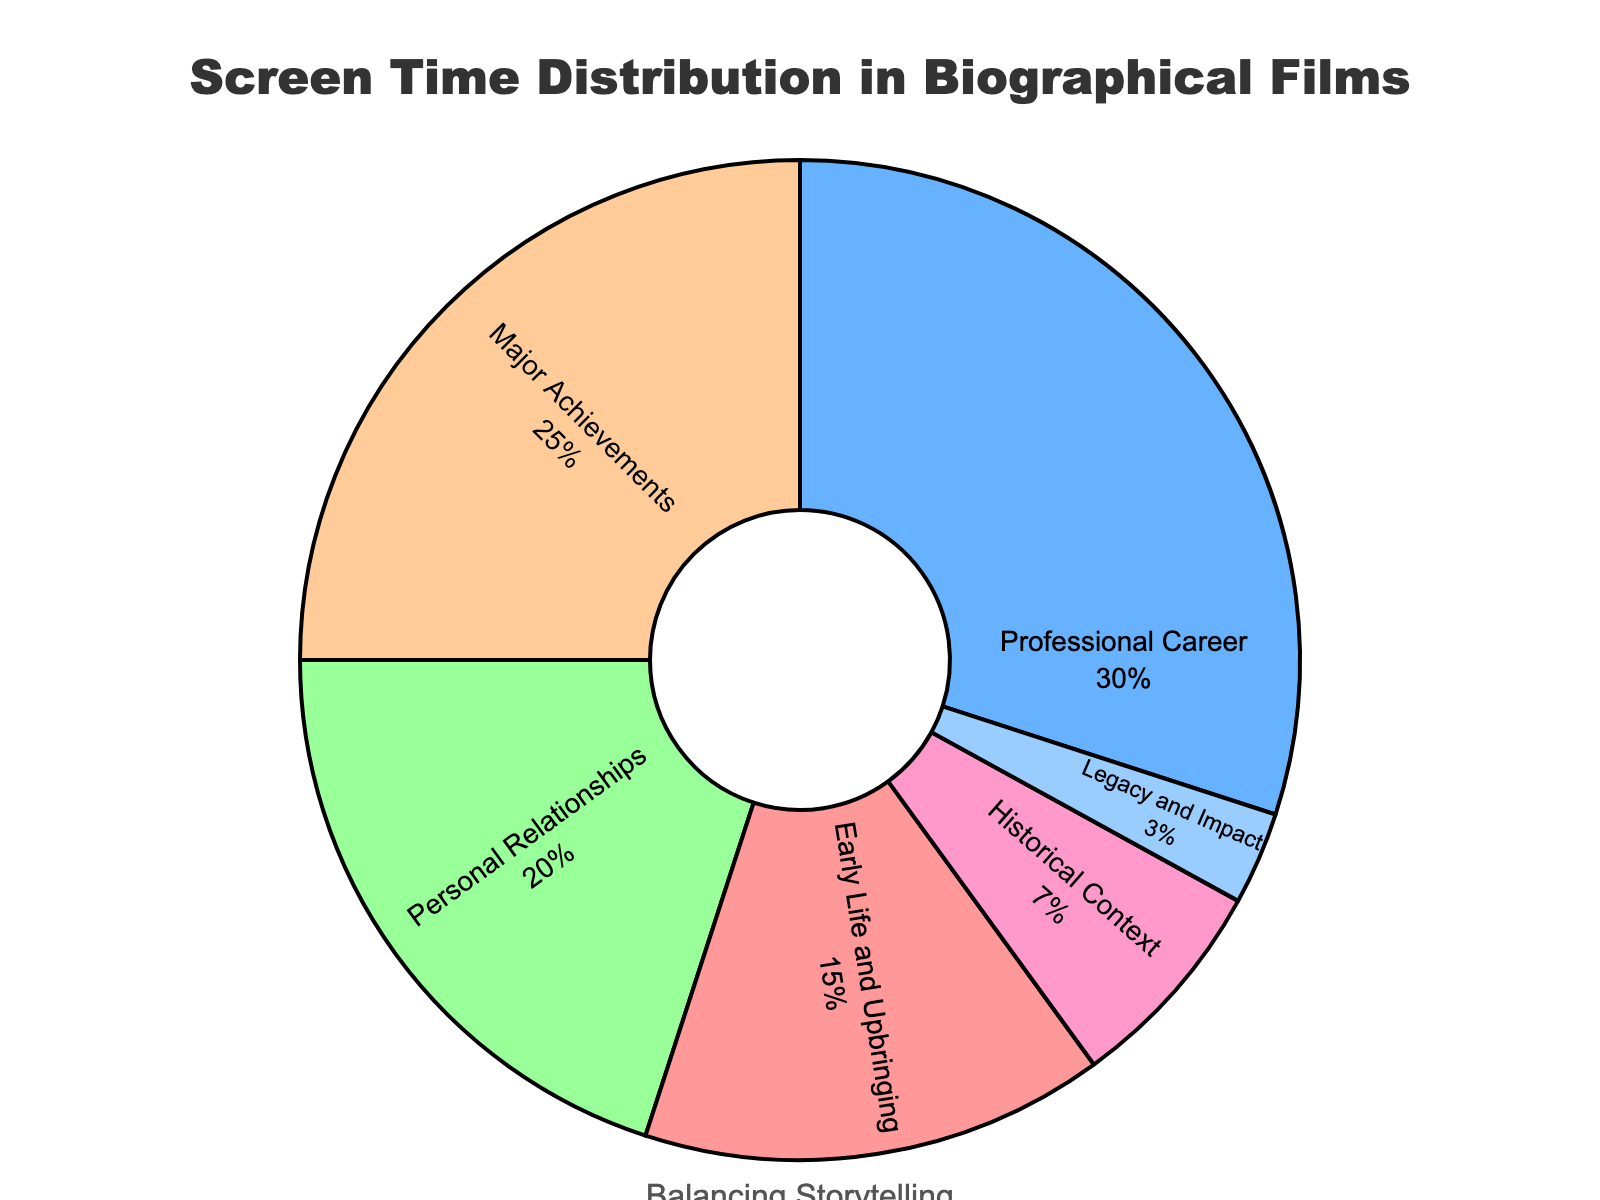Which aspect of the subject's life has the highest screen time percentage? Identify the segment with the largest proportion in the pie chart by comparing the percentages labeled for each aspect directly.
Answer: Professional Career How much more screen time is dedicated to Major Achievements than to Historical Context? Subtract the percentage of Historical Context (7%) from the percentage of Major Achievements (25%).
Answer: 18% Which two aspects combined take up exactly half of the screen time? Add the percentages of different pairs of aspects to find the pair that sums up to 50%. Early Life and Upbringing (15%) + Professional Career (30%) = 45%, Early Life and Upbringing (15%) + Personal Relationships (20%) = 35%, Professional Career (30%) + Personal Relationships (20%) = 50%.
Answer: Professional Career and Personal Relationships What percentage of the screen time is dedicated to the subject's life excluding their Professional Career? Subtract the percentage of Professional Career (30%) from 100% to get the remaining percentage.
Answer: 70% What is the difference in screen time between the aspects with the second highest and the third highest percentages? Identify the second highest (Major Achievements, 25%) and third highest percentages (Personal Relationships, 20%), and subtract the third highest from the second highest.
Answer: 5% Which aspect has the smallest proportion of screen time, and what is it? Look for the segment with the smallest percentage labeled in the pie chart.
Answer: Legacy and Impact, 3% Is more screen time allocated to Personal Relationships or Legacy and Impact combined than to Major Achievements? Add the percentages of Personal Relationships (20%) and Legacy and Impact (3%) and compare it with Major Achievements (25%). 20% + 3% = 23%, which is less than 25%.
Answer: No How much total screen time is given to aspects related to the subject's career and achievements? Add the percentages of Professional Career (30%) and Major Achievements (25%).
Answer: 55% By what percentage does screen time for Early Life and Upbringing exceed that of Historical Context? Subtract the percentage of Historical Context (7%) from Early Life and Upbringing (15%) and directly get the result.
Answer: 8% How many aspects of the subject's life have a screen time less than 10%? Count the segments with percentages less than 10%: Historical Context (7%) and Legacy and Impact (3%).
Answer: 2 